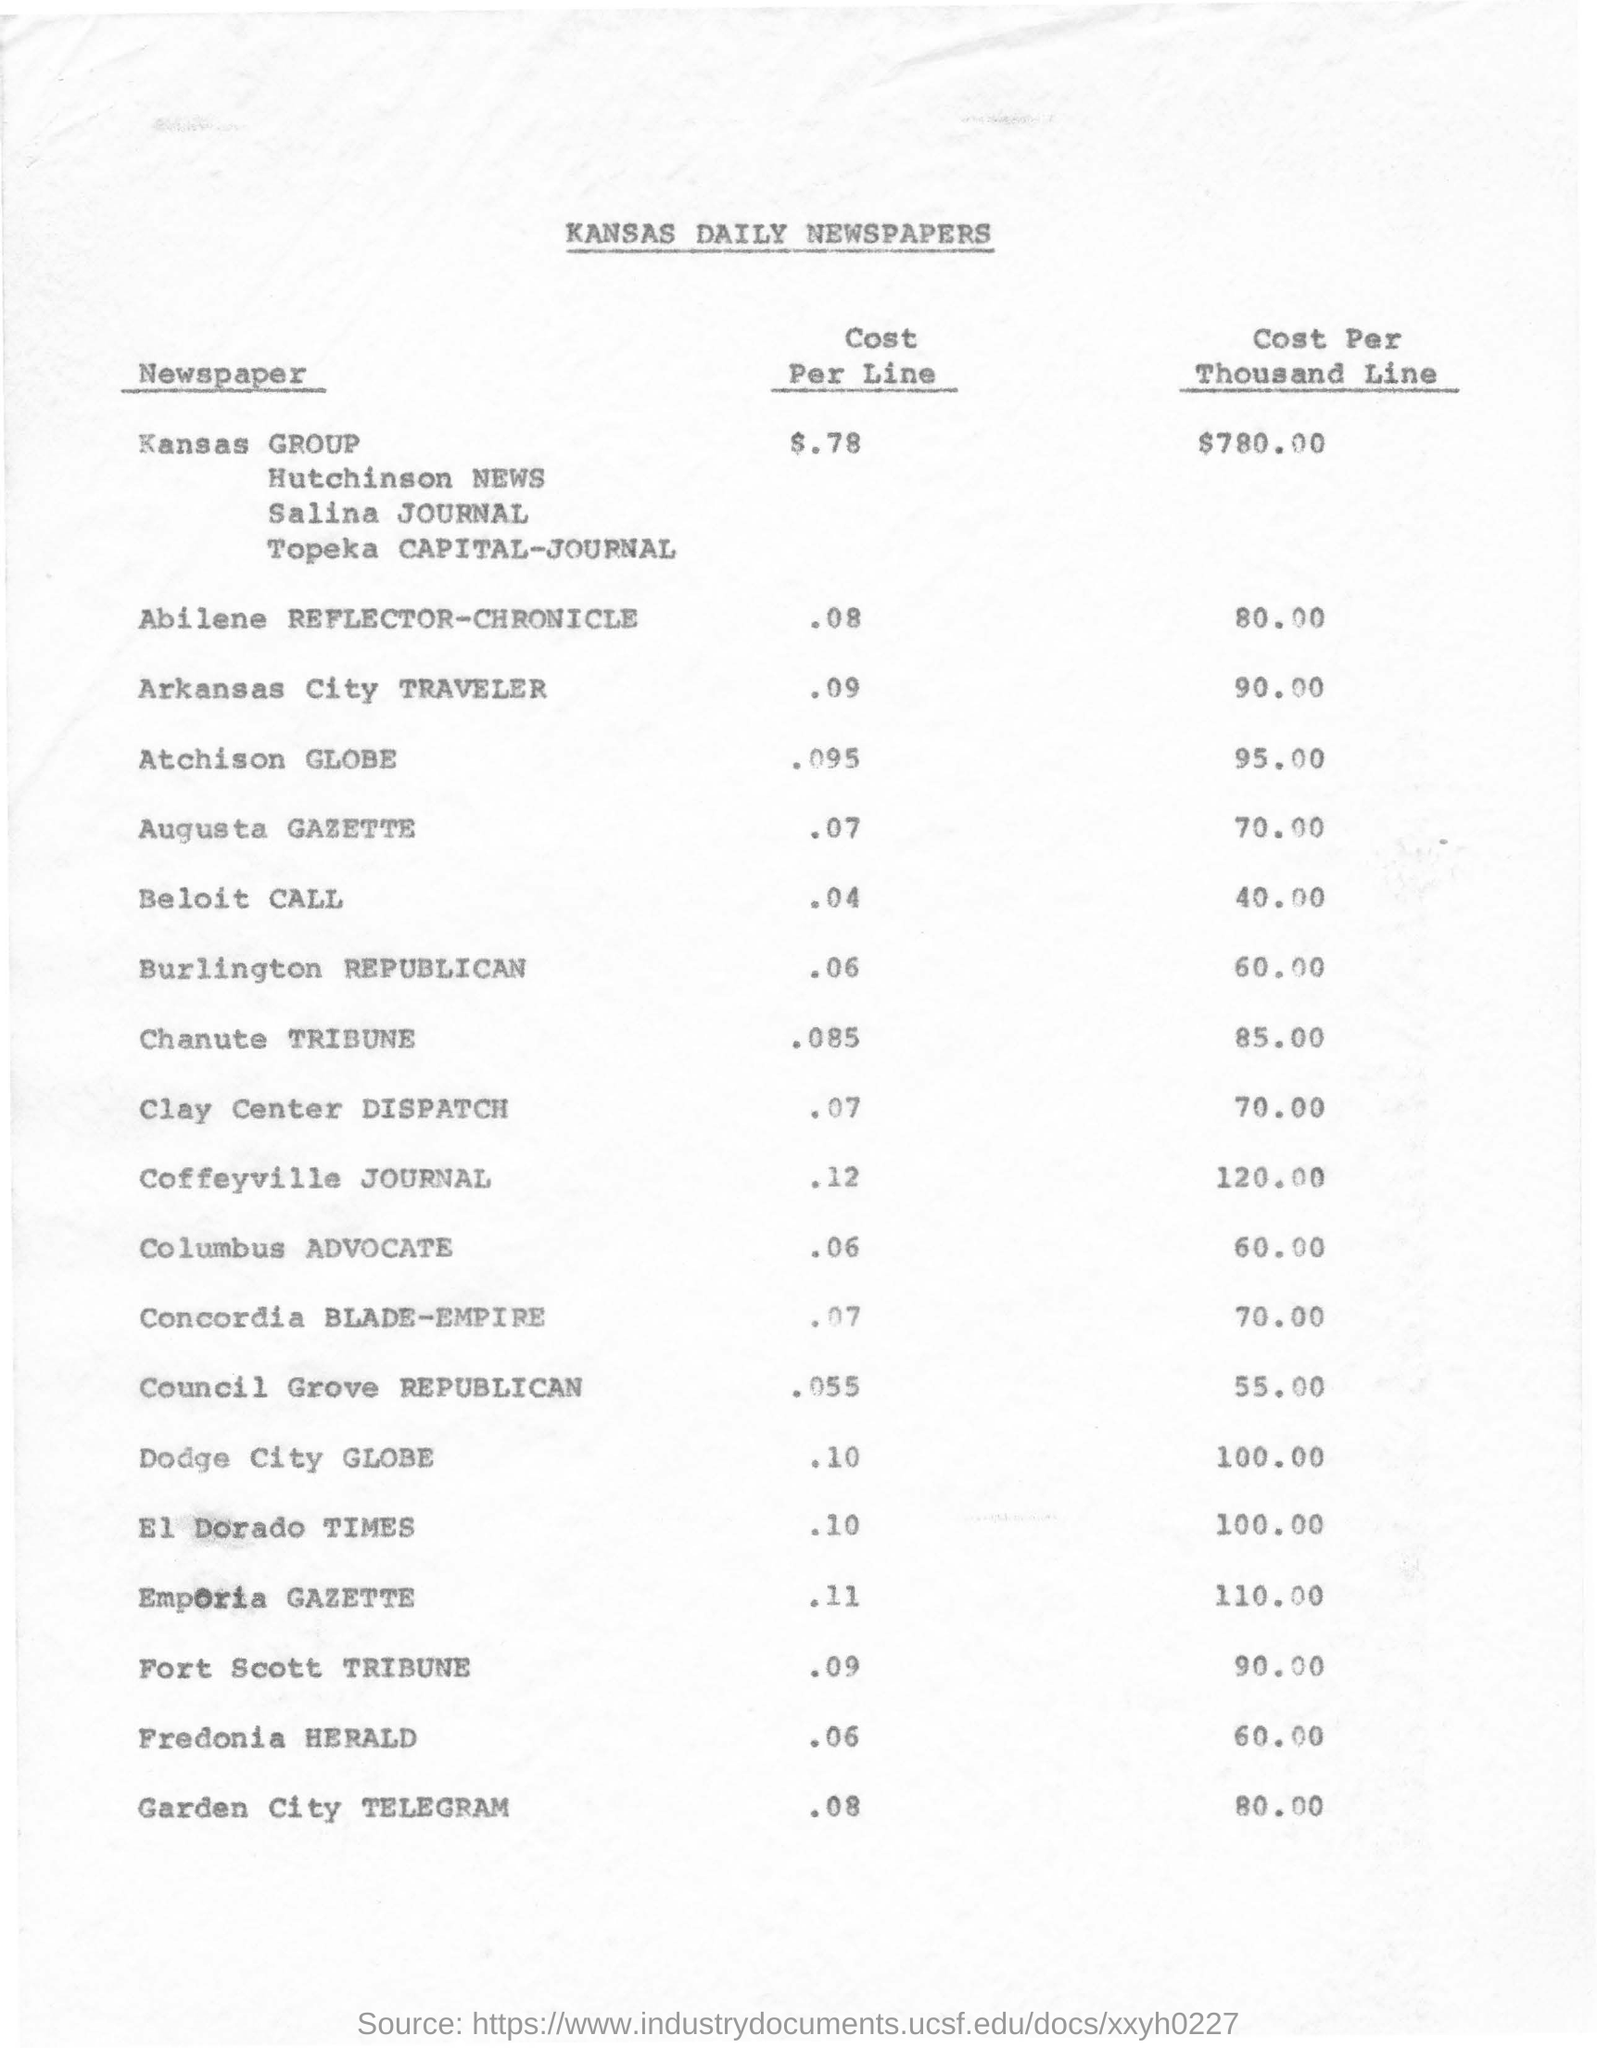What is the Head line of the document
Keep it short and to the point. KANSAS DAILY NEWSPAPERS. What is the cost of Garden City TELEGRAM in cost per thousand line
Provide a short and direct response. 80.00. 